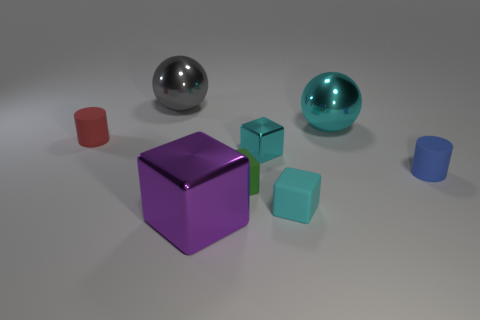Are there any tiny matte cylinders on the left side of the big object in front of the tiny cylinder that is left of the tiny cyan rubber thing?
Offer a very short reply. Yes. The blue thing that is the same size as the green thing is what shape?
Your answer should be compact. Cylinder. Do the cyan shiny block that is right of the tiny red thing and the cyan object that is behind the small red rubber cylinder have the same size?
Make the answer very short. No. What number of big cyan metal balls are there?
Your answer should be compact. 1. How big is the cylinder to the left of the cylinder in front of the small thing to the left of the gray metallic thing?
Give a very brief answer. Small. There is a small cyan metal object; what number of cubes are behind it?
Provide a short and direct response. 0. Are there the same number of tiny red cylinders left of the tiny red matte thing and tiny gray things?
Provide a short and direct response. Yes. What number of objects are either small green matte things or cyan things?
Your response must be concise. 4. What shape is the cyan shiny object that is in front of the small object that is to the left of the purple thing?
Make the answer very short. Cube. What shape is the small thing that is the same material as the large purple object?
Ensure brevity in your answer.  Cube. 